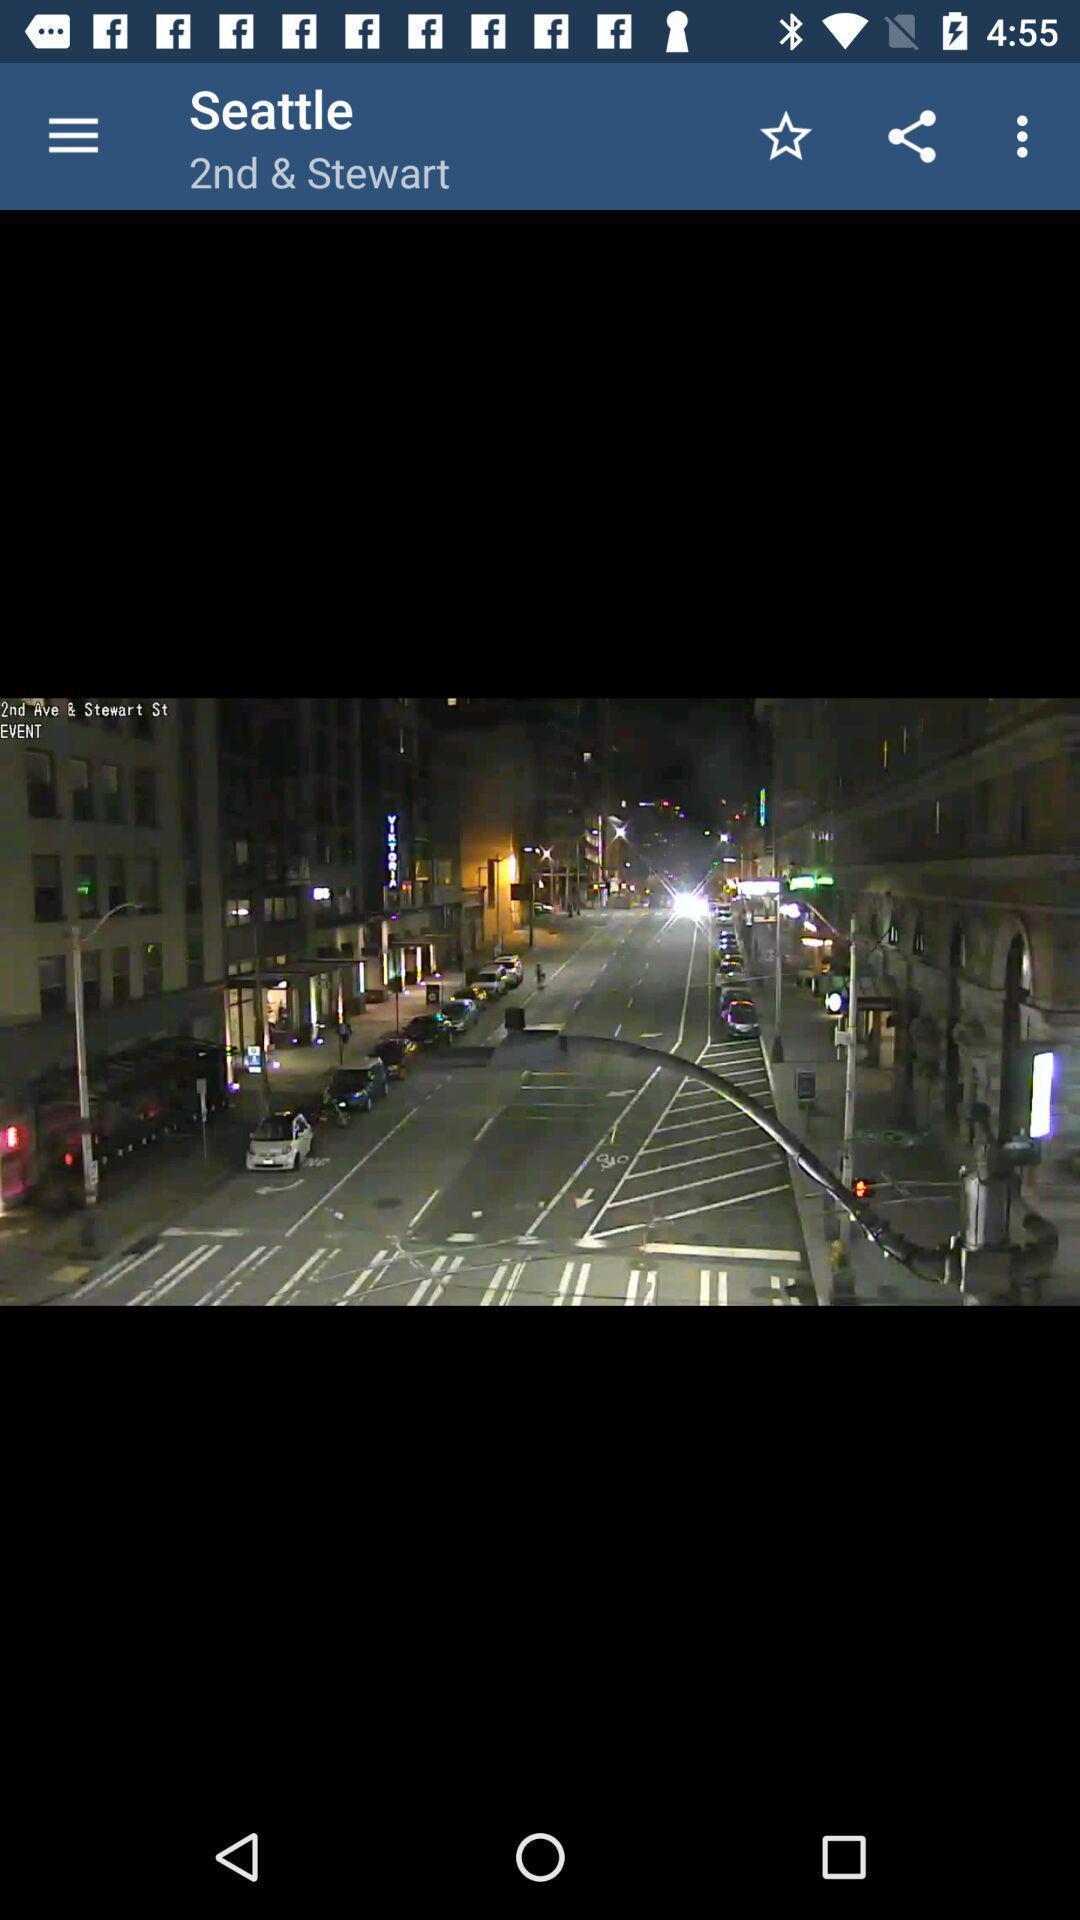Provide a detailed account of this screenshot. Page displays street view image. 